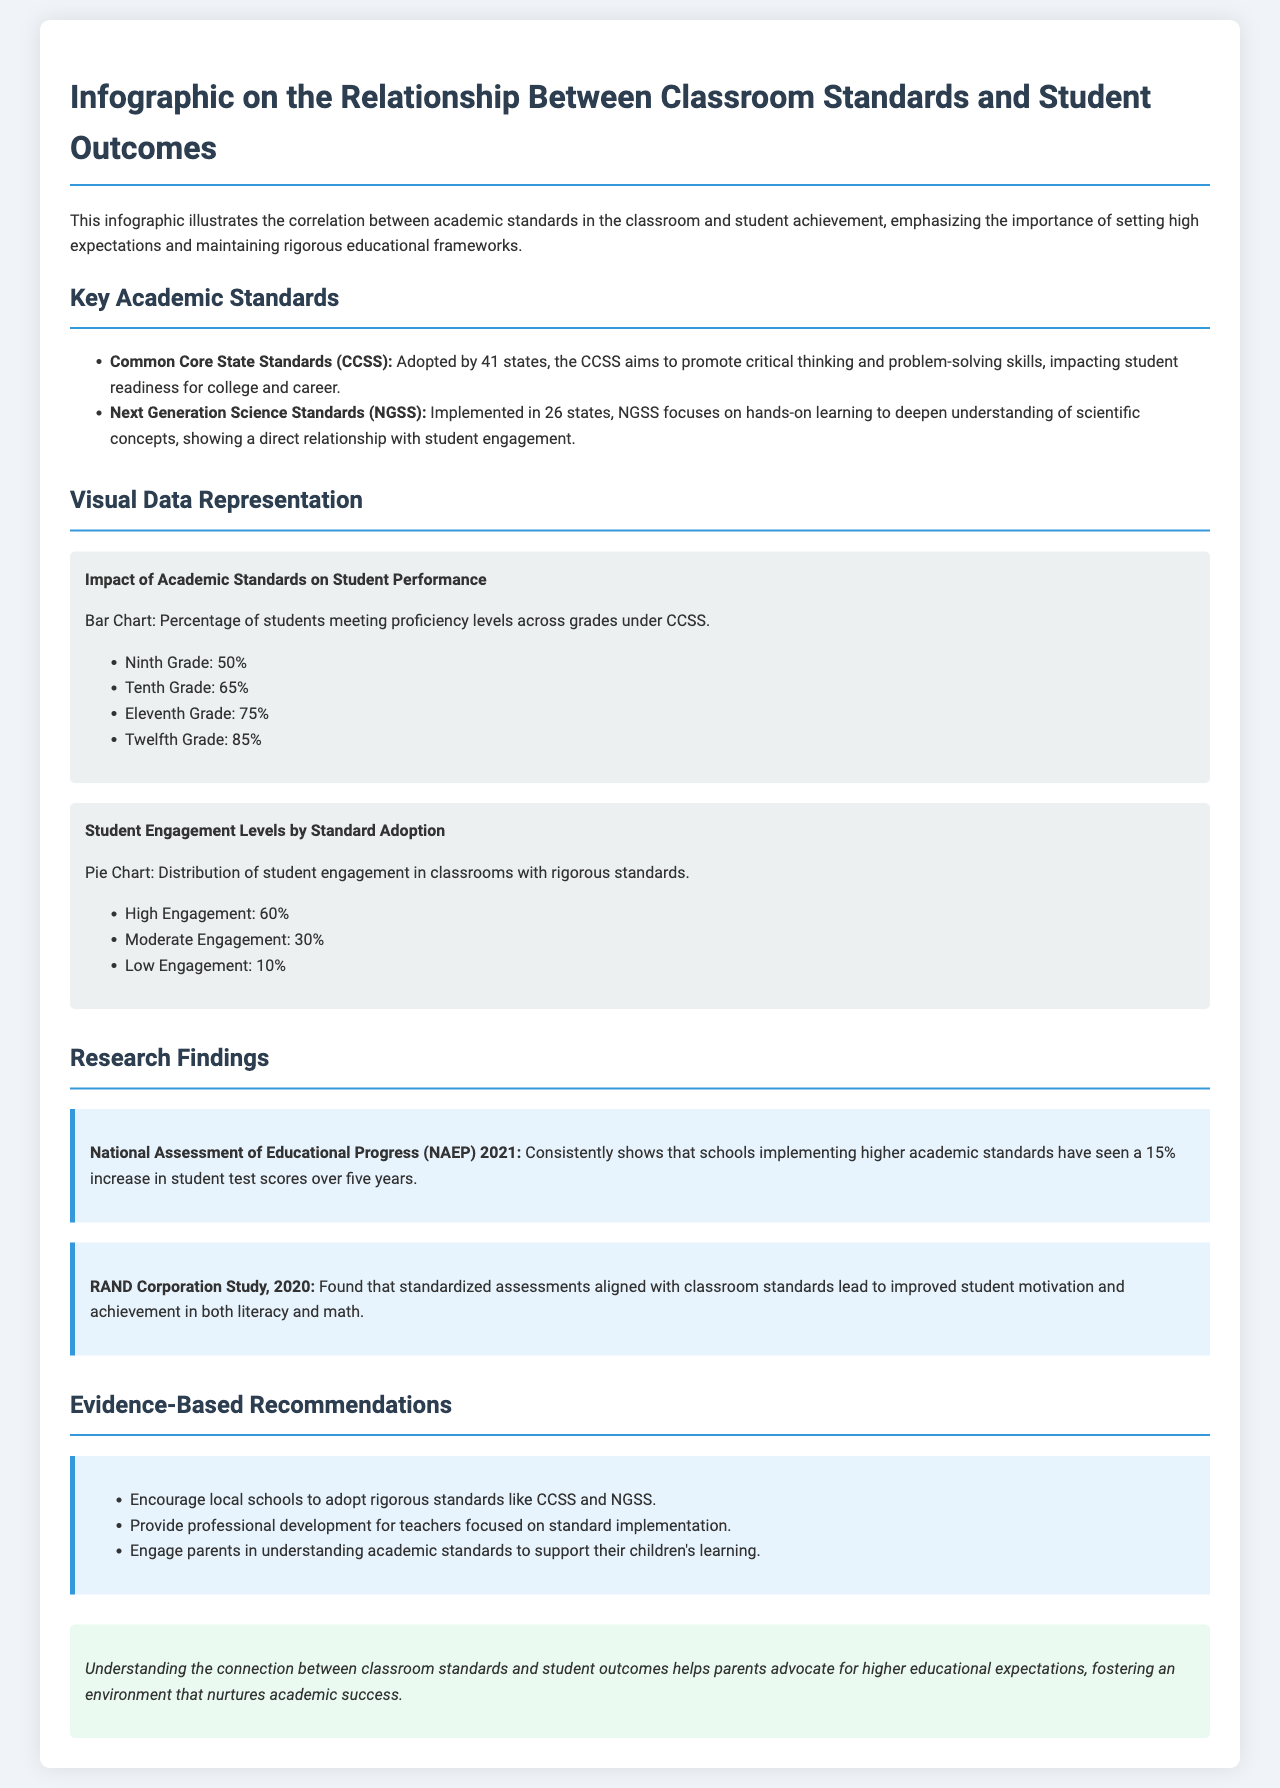What are the Common Core State Standards? The Common Core State Standards aim to promote critical thinking and problem-solving skills, impacting student readiness for college and career.
Answer: Promote critical thinking and problem-solving skills What percentage of ninth graders meet proficiency levels under CCSS? The document states that 50% of ninth graders meet proficiency levels under CCSS from the visual data representation.
Answer: 50% How many states have implemented the Next Generation Science Standards? The document notes that Next Generation Science Standards have been implemented in 26 states.
Answer: 26 states What percentage of students reported high engagement in classrooms with rigorous standards? The document indicates that 60% of students reported high engagement in classrooms with rigorous standards based on the pie chart.
Answer: 60% What increase in test scores did schools implementing higher academic standards see according to NAEP 2021? The findings from NAEP 2021 state there was a 15% increase in student test scores over five years.
Answer: 15% What is one recommendation to support understanding of academic standards? The document recommends engaging parents in understanding academic standards to support their children's learning.
Answer: Engage parents Which educational framework is emphasized for professional development? The document states that professional development for teachers should focus on the implementation of rigorous standards like CCSS and NGSS.
Answer: CCSS and NGSS 